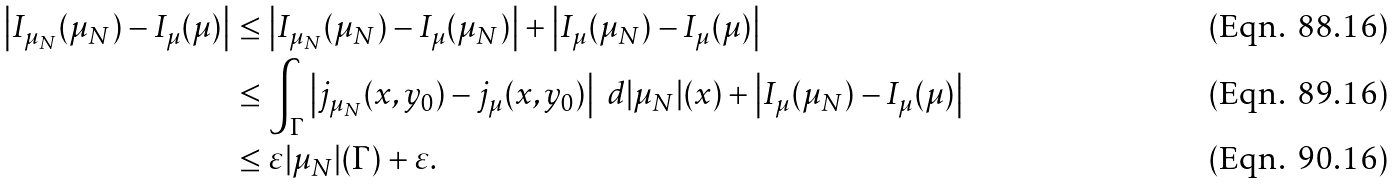Convert formula to latex. <formula><loc_0><loc_0><loc_500><loc_500>\left | I _ { \mu _ { N } } ( \mu _ { N } ) - I _ { \mu } ( \mu ) \right | & \leq \left | I _ { \mu _ { N } } ( \mu _ { N } ) - I _ { \mu } ( \mu _ { N } ) \right | + \left | I _ { \mu } ( \mu _ { N } ) - I _ { \mu } ( \mu ) \right | \\ & \leq \int _ { \Gamma } \left | j _ { \mu _ { N } } ( x , y _ { 0 } ) - j _ { \mu } ( x , y _ { 0 } ) \right | \ d | \mu _ { N } | ( x ) + \left | I _ { \mu } ( \mu _ { N } ) - I _ { \mu } ( \mu ) \right | \\ & \leq \varepsilon | \mu _ { N } | ( \Gamma ) + \varepsilon .</formula> 